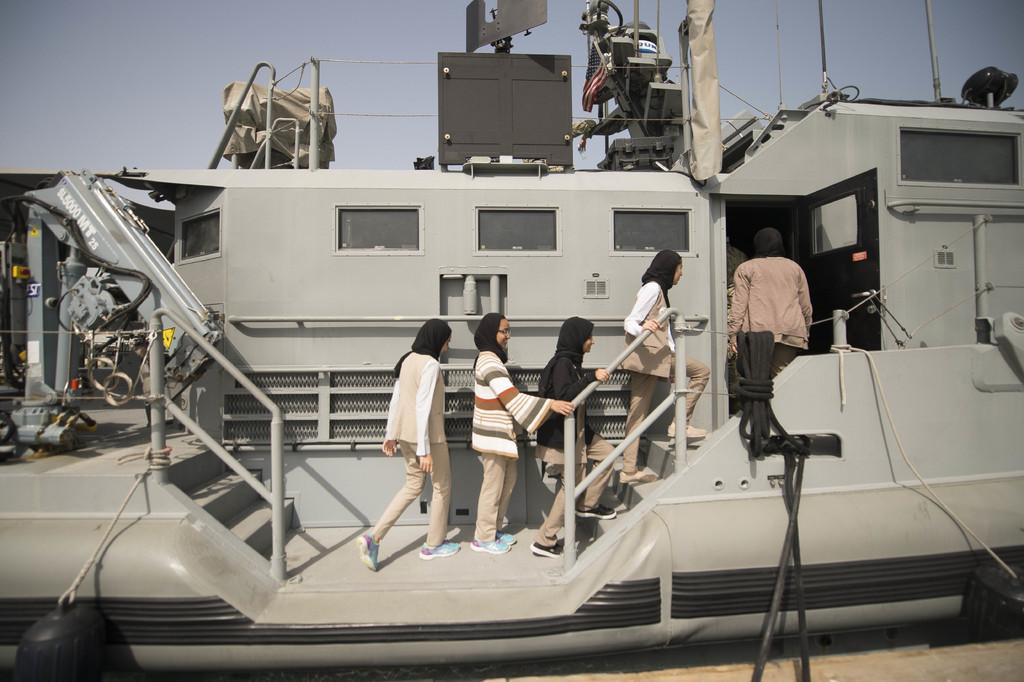Who or what is present in the image? There are people in the image. What are the people doing or where are they located? The people appear to be in a boat. What can be seen in the background of the image? The sky is visible in the background of the image. Where is the drain located in the image? There is no drain present in the image. What type of coat is the dad wearing in the image? There is no dad or coat present in the image. 